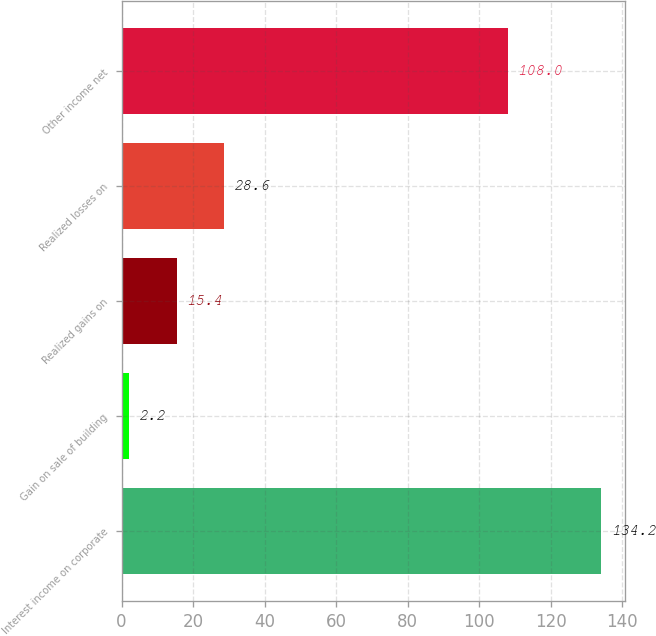Convert chart to OTSL. <chart><loc_0><loc_0><loc_500><loc_500><bar_chart><fcel>Interest income on corporate<fcel>Gain on sale of building<fcel>Realized gains on<fcel>Realized losses on<fcel>Other income net<nl><fcel>134.2<fcel>2.2<fcel>15.4<fcel>28.6<fcel>108<nl></chart> 